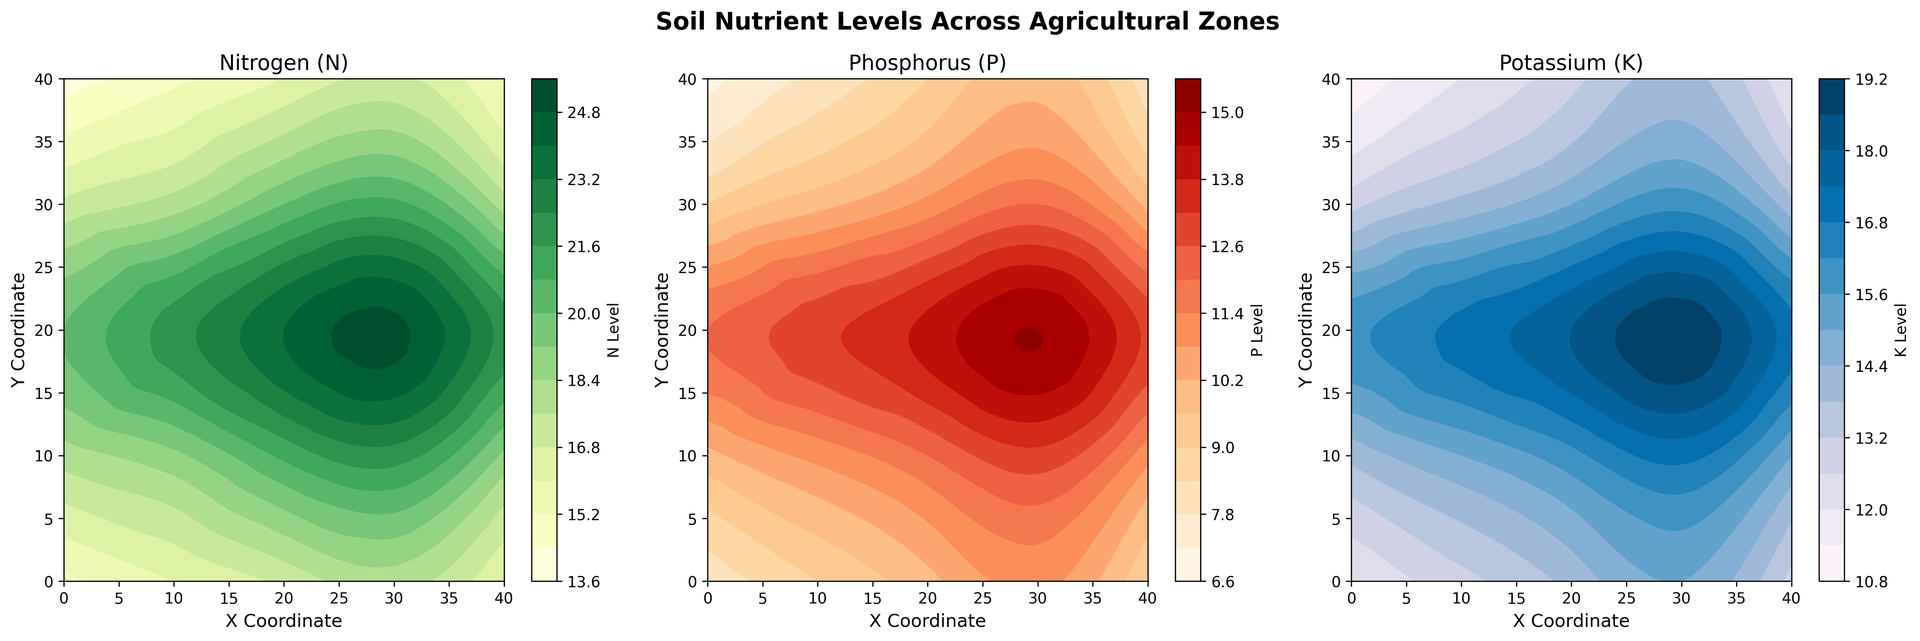What is the highest nitrogen level observed in the village? By looking at the nitrogen contour plot, identify the region where the nitrogen level is at its peak. The darkest green areas indicate the highest concentration.
Answer: 25 Which agricultural zone has the highest concentration of potassium? Examine the potassium contour plot for the darkest blue areas that indicate the highest potassium levels. Cross-reference with the x and y coordinates displayed.
Answer: Around (30,20) Compare the phosphorus levels at coordinates (0,20) and (20,40). Which is higher? Identify the specific phosphorus levels at these coordinates by locating them on the phosphorus contour plot and observing the color intensity.
Answer: (0,20) What is the average nitrogen level between coordinates (10,10) and (30,30)? First, determine the nitrogen levels at (10,10) and (30,30) from the nitrogen plot. Add these levels and then divide by 2 to find the average.
Answer: (19 + 21)/2 = 20 In which zone does the phosphorus level exceed 10 units but stays below 13 units? Look for areas in the phosphorus contour plot where the color is within the range representing 10-13 units. Check the corresponding x and y coordinates.
Answer: Around (20, 30) How does the potassium level change from (0,0) to (40,40)? Track the gradient and color intensity changes on the potassium plot as you move from (0,0) to (40,40). Clearly, identify the upward or downward trend in levels.
Answer: Decreases Which coordinate has the lowest nitrogen level? Observe the nitrogen contour plot to find the lightest green area which signifies the lowest nitrogen level. Cross-reference it with its coordinates.
Answer: Around (0,0) or (0,40) How do the phosphorus levels at (10,0) and (30,10) compare? Locate the points (10,0) and (30,10) on the phosphorus contour plot and compare the levels visually.
Answer: Nearly the same Describe the visual differences between the nitrogen and potassium distribution patterns. Compare the green areas of the nitrogen plot and the blue areas of the potassium plot. Notice any distinct patterns or clustering in specific agricultural zones.
Answer: Nitrogen is higher in central zones; potassium shows more variability across zones What is the average potassium level across all zones? Integrate potassium levels visually from the potassium plot or use the given data for a more precise calculation.
Answer: (Sum of all potassium levels)/25 = 15 